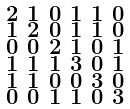<formula> <loc_0><loc_0><loc_500><loc_500>\begin{smallmatrix} 2 & 1 & 0 & 1 & 1 & 0 \\ 1 & 2 & 0 & 1 & 1 & 0 \\ 0 & 0 & 2 & 1 & 0 & 1 \\ 1 & 1 & 1 & 3 & 0 & 1 \\ 1 & 1 & 0 & 0 & 3 & 0 \\ 0 & 0 & 1 & 1 & 0 & 3 \end{smallmatrix}</formula> 